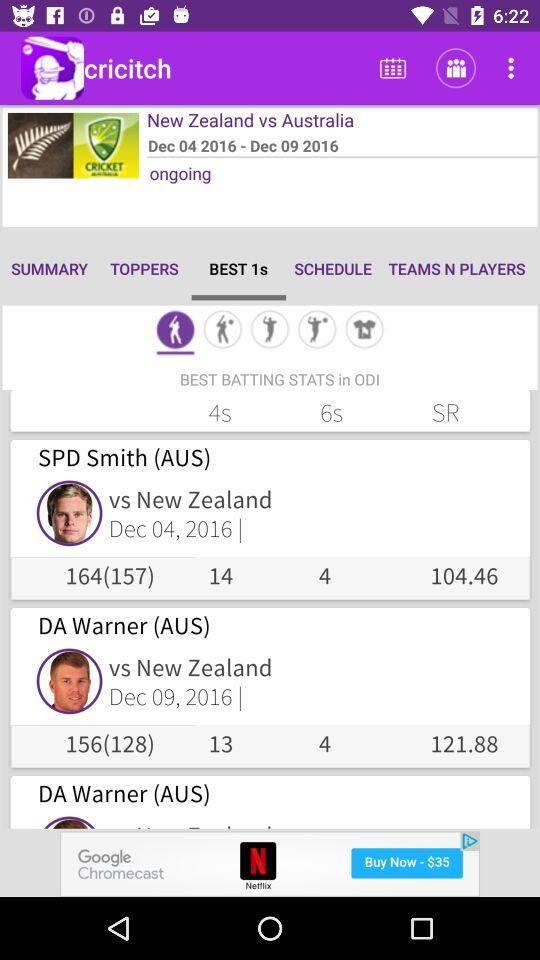Which option is selected? The selected option is "BEST 1s". 